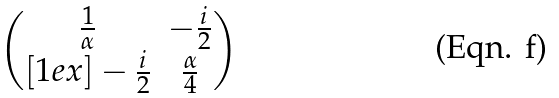<formula> <loc_0><loc_0><loc_500><loc_500>\begin{pmatrix} \frac { 1 } { \alpha } & - \frac { i } { 2 } \\ [ 1 e x ] - \frac { i } { 2 } & \frac { \alpha } { 4 } \end{pmatrix}</formula> 